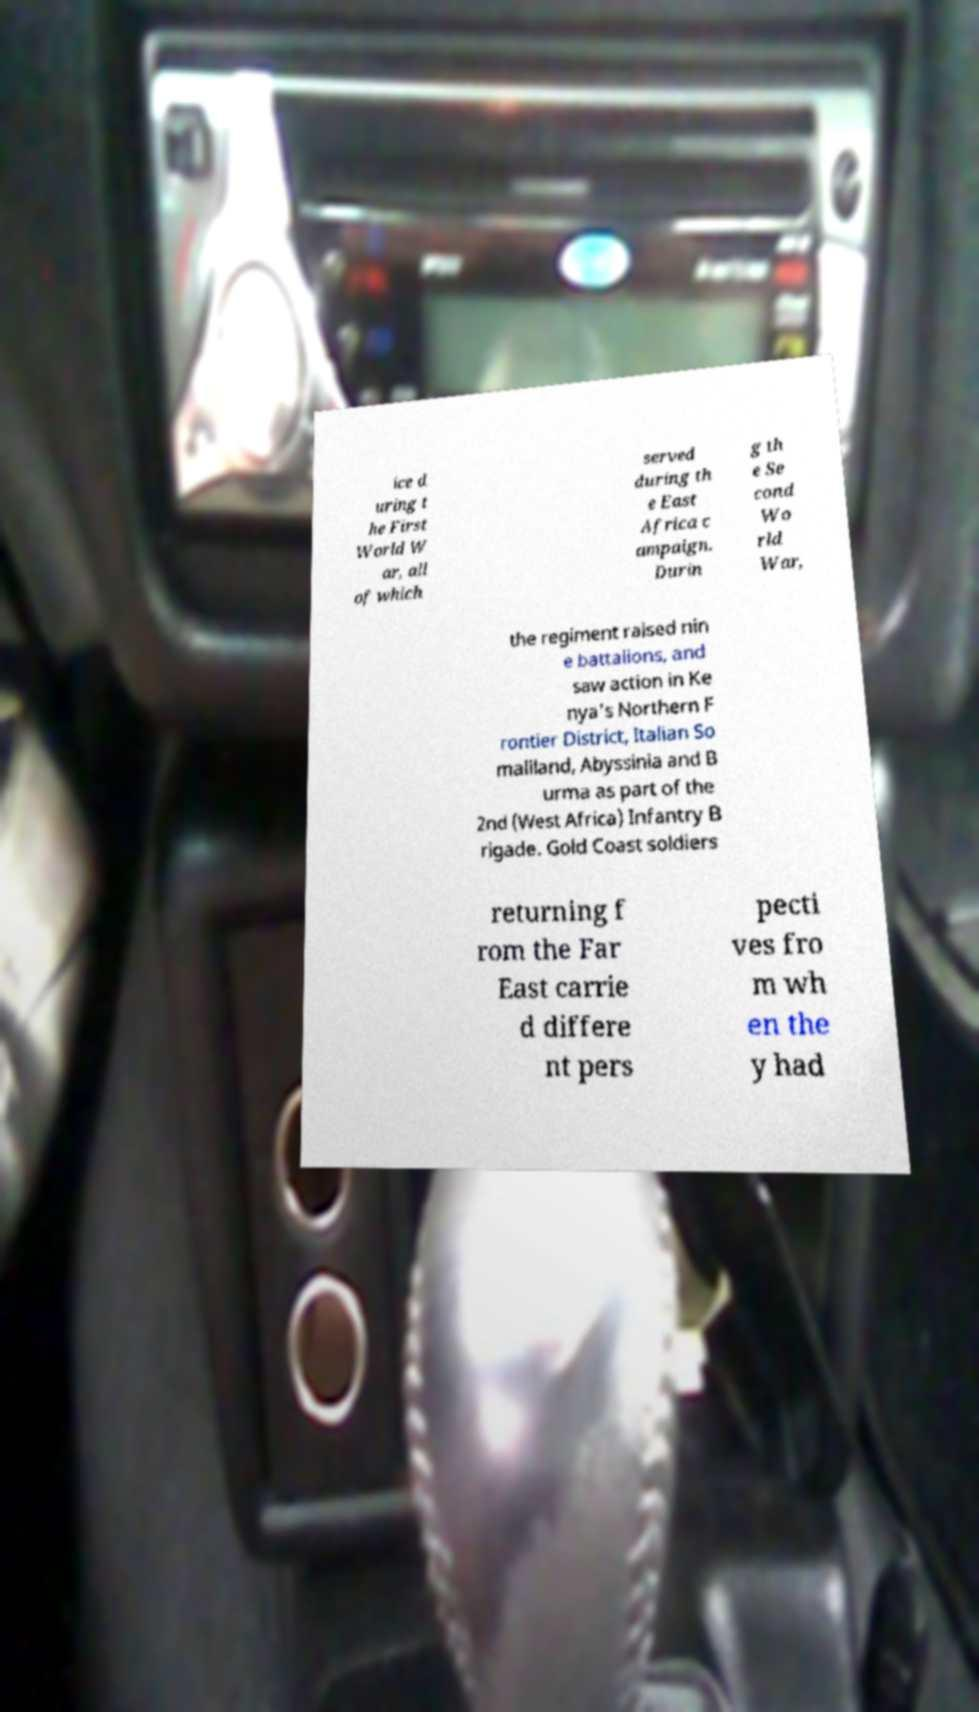Can you read and provide the text displayed in the image?This photo seems to have some interesting text. Can you extract and type it out for me? ice d uring t he First World W ar, all of which served during th e East Africa c ampaign. Durin g th e Se cond Wo rld War, the regiment raised nin e battalions, and saw action in Ke nya's Northern F rontier District, Italian So maliland, Abyssinia and B urma as part of the 2nd (West Africa) Infantry B rigade. Gold Coast soldiers returning f rom the Far East carrie d differe nt pers pecti ves fro m wh en the y had 